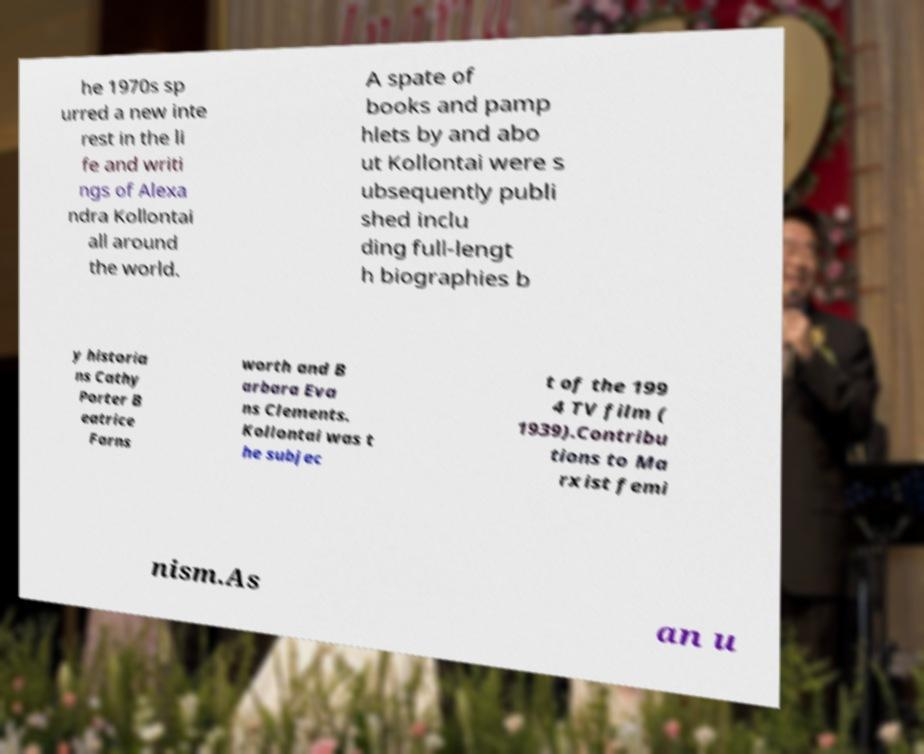Please read and relay the text visible in this image. What does it say? he 1970s sp urred a new inte rest in the li fe and writi ngs of Alexa ndra Kollontai all around the world. A spate of books and pamp hlets by and abo ut Kollontai were s ubsequently publi shed inclu ding full-lengt h biographies b y historia ns Cathy Porter B eatrice Farns worth and B arbara Eva ns Clements. Kollontai was t he subjec t of the 199 4 TV film ( 1939).Contribu tions to Ma rxist femi nism.As an u 